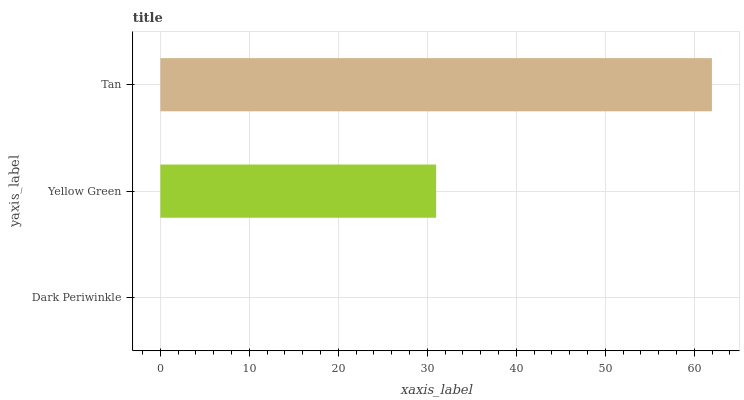Is Dark Periwinkle the minimum?
Answer yes or no. Yes. Is Tan the maximum?
Answer yes or no. Yes. Is Yellow Green the minimum?
Answer yes or no. No. Is Yellow Green the maximum?
Answer yes or no. No. Is Yellow Green greater than Dark Periwinkle?
Answer yes or no. Yes. Is Dark Periwinkle less than Yellow Green?
Answer yes or no. Yes. Is Dark Periwinkle greater than Yellow Green?
Answer yes or no. No. Is Yellow Green less than Dark Periwinkle?
Answer yes or no. No. Is Yellow Green the high median?
Answer yes or no. Yes. Is Yellow Green the low median?
Answer yes or no. Yes. Is Dark Periwinkle the high median?
Answer yes or no. No. Is Dark Periwinkle the low median?
Answer yes or no. No. 